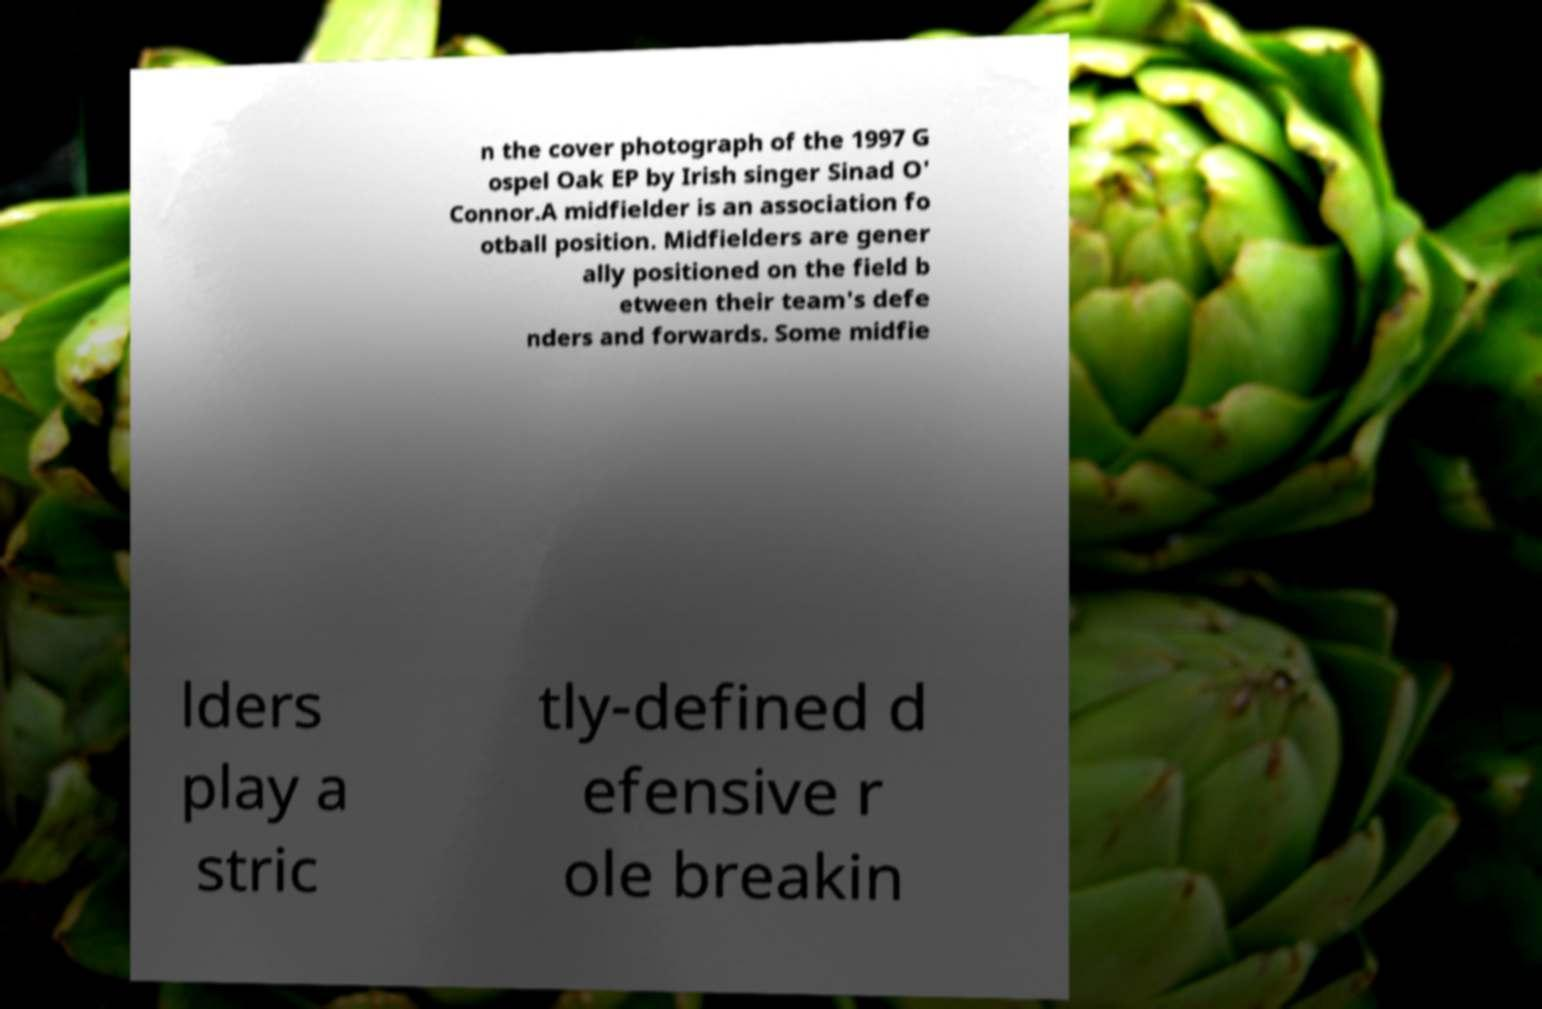What messages or text are displayed in this image? I need them in a readable, typed format. n the cover photograph of the 1997 G ospel Oak EP by Irish singer Sinad O' Connor.A midfielder is an association fo otball position. Midfielders are gener ally positioned on the field b etween their team's defe nders and forwards. Some midfie lders play a stric tly-defined d efensive r ole breakin 